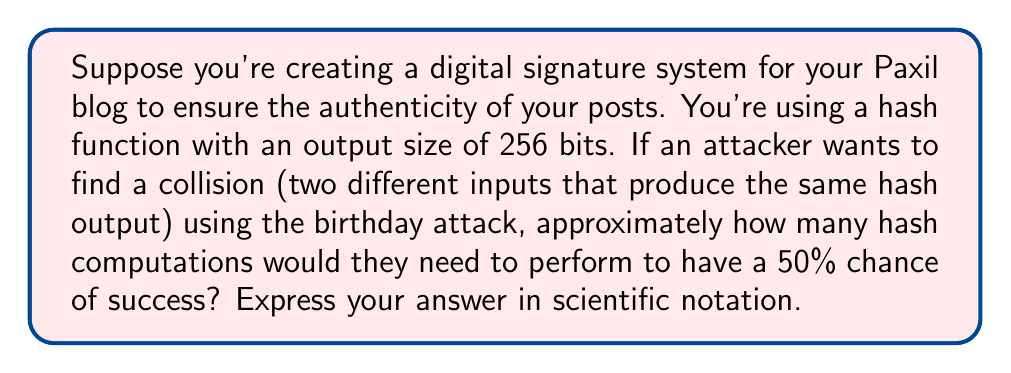Show me your answer to this math problem. To solve this problem, we'll use the birthday attack probability formula and the properties of hash functions:

1. The output size of the hash function is 256 bits, so the total number of possible hash values is $2^{256}$.

2. The birthday attack exploits the birthday paradox to find collisions more efficiently than brute force.

3. The formula for the number of attempts needed for a 50% chance of finding a collision is:

   $$n \approx \sqrt{2 \ln(2) \cdot 2^m}$$

   Where $n$ is the number of attempts and $m$ is the number of bits in the hash output.

4. Substituting $m = 256$ into the formula:

   $$n \approx \sqrt{2 \ln(2) \cdot 2^{256}}$$

5. Simplify:
   $$n \approx \sqrt{2 \cdot 0.693 \cdot 2^{256}}$$
   $$n \approx \sqrt{1.386 \cdot 2^{256}}$$

6. Evaluate:
   $$n \approx 1.18 \cdot 2^{128}$$

7. Convert to scientific notation:
   $$n \approx 1.18 \cdot 2^{128} \approx 1.18 \cdot 3.40 \cdot 10^{38} \approx 4.01 \cdot 10^{38}$$
Answer: $4.01 \cdot 10^{38}$ 